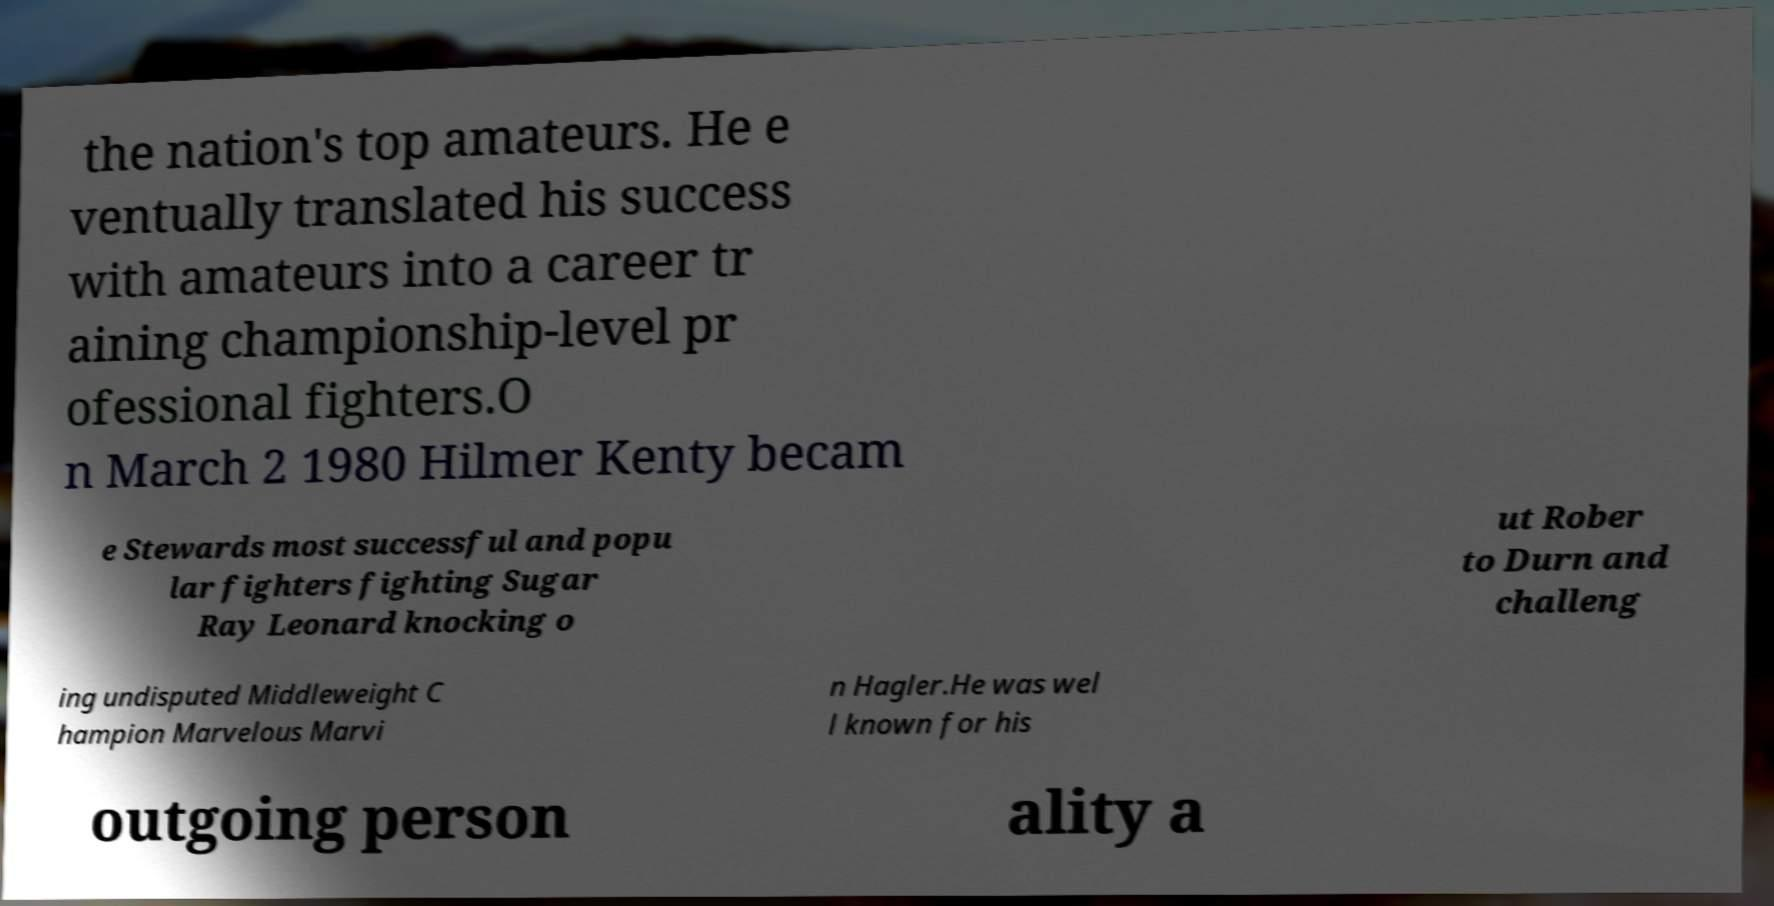Can you accurately transcribe the text from the provided image for me? the nation's top amateurs. He e ventually translated his success with amateurs into a career tr aining championship-level pr ofessional fighters.O n March 2 1980 Hilmer Kenty becam e Stewards most successful and popu lar fighters fighting Sugar Ray Leonard knocking o ut Rober to Durn and challeng ing undisputed Middleweight C hampion Marvelous Marvi n Hagler.He was wel l known for his outgoing person ality a 